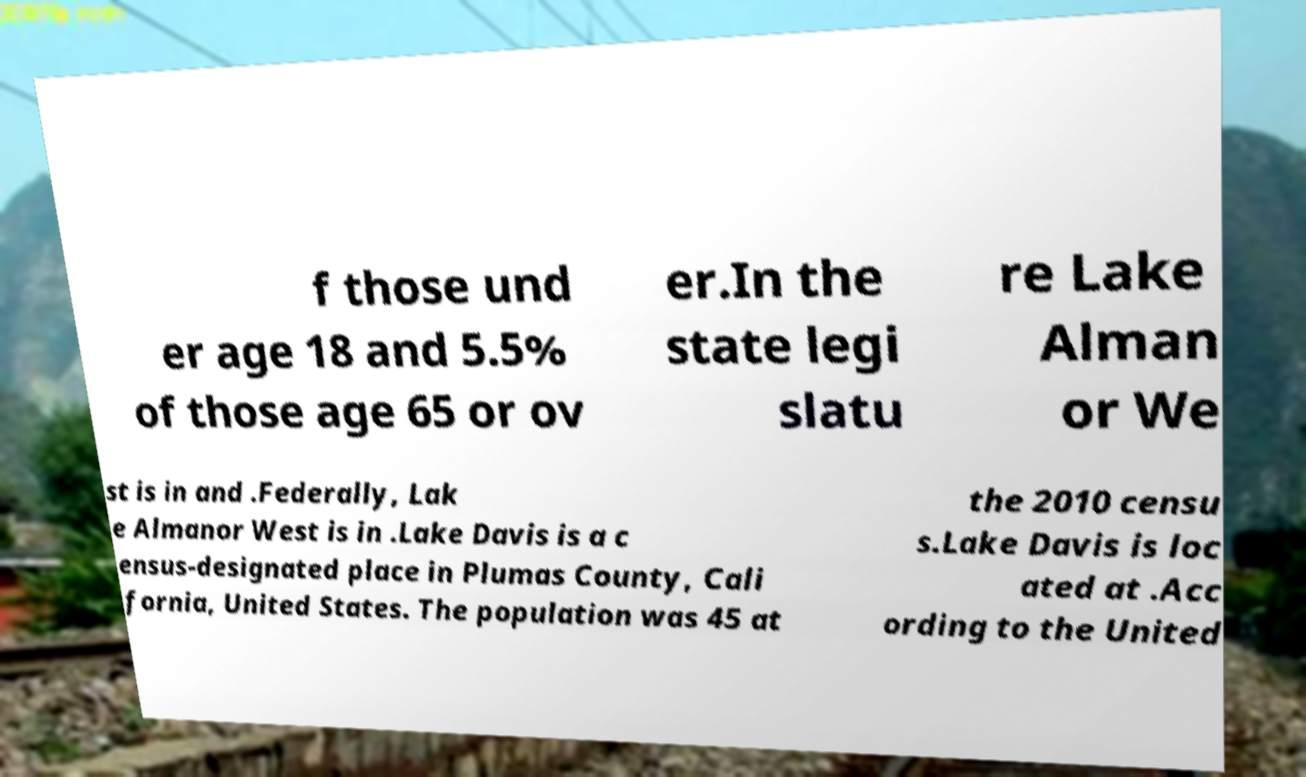Can you read and provide the text displayed in the image?This photo seems to have some interesting text. Can you extract and type it out for me? f those und er age 18 and 5.5% of those age 65 or ov er.In the state legi slatu re Lake Alman or We st is in and .Federally, Lak e Almanor West is in .Lake Davis is a c ensus-designated place in Plumas County, Cali fornia, United States. The population was 45 at the 2010 censu s.Lake Davis is loc ated at .Acc ording to the United 